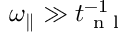<formula> <loc_0><loc_0><loc_500><loc_500>{ \omega _ { \| } } \gg t _ { n l } ^ { - 1 }</formula> 